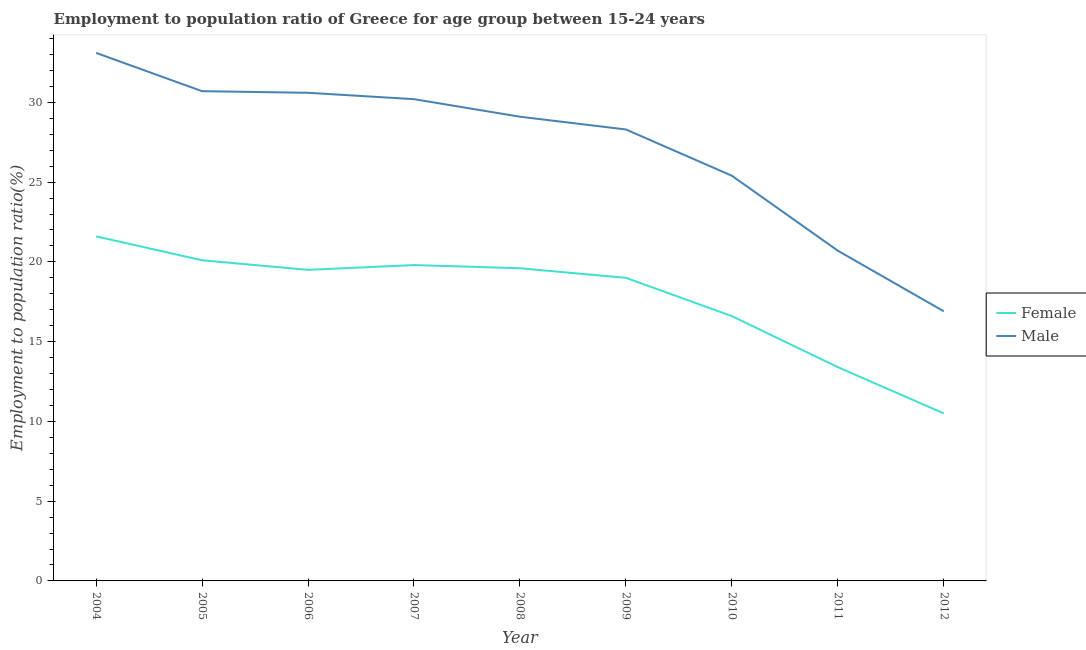How many different coloured lines are there?
Provide a short and direct response. 2. What is the employment to population ratio(male) in 2009?
Give a very brief answer. 28.3. Across all years, what is the maximum employment to population ratio(female)?
Keep it short and to the point. 21.6. What is the total employment to population ratio(male) in the graph?
Ensure brevity in your answer.  245. What is the difference between the employment to population ratio(female) in 2005 and that in 2006?
Offer a terse response. 0.6. What is the difference between the employment to population ratio(female) in 2007 and the employment to population ratio(male) in 2010?
Offer a very short reply. -5.6. What is the average employment to population ratio(male) per year?
Offer a very short reply. 27.22. In the year 2005, what is the difference between the employment to population ratio(male) and employment to population ratio(female)?
Make the answer very short. 10.6. What is the ratio of the employment to population ratio(male) in 2005 to that in 2009?
Keep it short and to the point. 1.08. Is the employment to population ratio(male) in 2004 less than that in 2006?
Your answer should be very brief. No. What is the difference between the highest and the second highest employment to population ratio(male)?
Your answer should be very brief. 2.4. What is the difference between the highest and the lowest employment to population ratio(male)?
Make the answer very short. 16.2. In how many years, is the employment to population ratio(female) greater than the average employment to population ratio(female) taken over all years?
Provide a short and direct response. 6. Is the sum of the employment to population ratio(female) in 2005 and 2012 greater than the maximum employment to population ratio(male) across all years?
Your answer should be compact. No. Is the employment to population ratio(female) strictly greater than the employment to population ratio(male) over the years?
Offer a terse response. No. Is the employment to population ratio(male) strictly less than the employment to population ratio(female) over the years?
Keep it short and to the point. No. How many lines are there?
Offer a terse response. 2. What is the difference between two consecutive major ticks on the Y-axis?
Give a very brief answer. 5. Are the values on the major ticks of Y-axis written in scientific E-notation?
Offer a terse response. No. Does the graph contain any zero values?
Make the answer very short. No. How are the legend labels stacked?
Provide a succinct answer. Vertical. What is the title of the graph?
Provide a succinct answer. Employment to population ratio of Greece for age group between 15-24 years. Does "International Tourists" appear as one of the legend labels in the graph?
Provide a short and direct response. No. What is the label or title of the Y-axis?
Offer a very short reply. Employment to population ratio(%). What is the Employment to population ratio(%) of Female in 2004?
Provide a succinct answer. 21.6. What is the Employment to population ratio(%) in Male in 2004?
Give a very brief answer. 33.1. What is the Employment to population ratio(%) in Female in 2005?
Offer a very short reply. 20.1. What is the Employment to population ratio(%) of Male in 2005?
Your answer should be very brief. 30.7. What is the Employment to population ratio(%) of Female in 2006?
Give a very brief answer. 19.5. What is the Employment to population ratio(%) of Male in 2006?
Offer a terse response. 30.6. What is the Employment to population ratio(%) in Female in 2007?
Provide a short and direct response. 19.8. What is the Employment to population ratio(%) in Male in 2007?
Your response must be concise. 30.2. What is the Employment to population ratio(%) in Female in 2008?
Provide a short and direct response. 19.6. What is the Employment to population ratio(%) in Male in 2008?
Offer a terse response. 29.1. What is the Employment to population ratio(%) in Male in 2009?
Provide a succinct answer. 28.3. What is the Employment to population ratio(%) of Female in 2010?
Keep it short and to the point. 16.6. What is the Employment to population ratio(%) of Male in 2010?
Your answer should be very brief. 25.4. What is the Employment to population ratio(%) in Female in 2011?
Offer a very short reply. 13.4. What is the Employment to population ratio(%) of Male in 2011?
Offer a terse response. 20.7. What is the Employment to population ratio(%) of Male in 2012?
Your response must be concise. 16.9. Across all years, what is the maximum Employment to population ratio(%) of Female?
Offer a terse response. 21.6. Across all years, what is the maximum Employment to population ratio(%) in Male?
Ensure brevity in your answer.  33.1. Across all years, what is the minimum Employment to population ratio(%) in Male?
Offer a very short reply. 16.9. What is the total Employment to population ratio(%) of Female in the graph?
Offer a terse response. 160.1. What is the total Employment to population ratio(%) in Male in the graph?
Your answer should be very brief. 245. What is the difference between the Employment to population ratio(%) of Male in 2004 and that in 2005?
Give a very brief answer. 2.4. What is the difference between the Employment to population ratio(%) in Female in 2004 and that in 2006?
Provide a succinct answer. 2.1. What is the difference between the Employment to population ratio(%) in Female in 2004 and that in 2007?
Provide a short and direct response. 1.8. What is the difference between the Employment to population ratio(%) of Male in 2004 and that in 2007?
Offer a terse response. 2.9. What is the difference between the Employment to population ratio(%) in Female in 2004 and that in 2009?
Offer a terse response. 2.6. What is the difference between the Employment to population ratio(%) in Female in 2004 and that in 2011?
Offer a very short reply. 8.2. What is the difference between the Employment to population ratio(%) in Male in 2004 and that in 2011?
Your response must be concise. 12.4. What is the difference between the Employment to population ratio(%) of Female in 2004 and that in 2012?
Provide a succinct answer. 11.1. What is the difference between the Employment to population ratio(%) of Male in 2004 and that in 2012?
Keep it short and to the point. 16.2. What is the difference between the Employment to population ratio(%) of Female in 2005 and that in 2006?
Provide a succinct answer. 0.6. What is the difference between the Employment to population ratio(%) of Male in 2005 and that in 2006?
Your answer should be compact. 0.1. What is the difference between the Employment to population ratio(%) of Male in 2005 and that in 2007?
Keep it short and to the point. 0.5. What is the difference between the Employment to population ratio(%) in Female in 2005 and that in 2009?
Your answer should be compact. 1.1. What is the difference between the Employment to population ratio(%) in Male in 2005 and that in 2010?
Keep it short and to the point. 5.3. What is the difference between the Employment to population ratio(%) of Female in 2005 and that in 2011?
Your answer should be compact. 6.7. What is the difference between the Employment to population ratio(%) of Male in 2006 and that in 2007?
Your answer should be compact. 0.4. What is the difference between the Employment to population ratio(%) of Female in 2006 and that in 2009?
Provide a short and direct response. 0.5. What is the difference between the Employment to population ratio(%) in Male in 2006 and that in 2009?
Ensure brevity in your answer.  2.3. What is the difference between the Employment to population ratio(%) of Female in 2006 and that in 2010?
Your answer should be very brief. 2.9. What is the difference between the Employment to population ratio(%) of Male in 2006 and that in 2010?
Keep it short and to the point. 5.2. What is the difference between the Employment to population ratio(%) in Male in 2006 and that in 2012?
Offer a terse response. 13.7. What is the difference between the Employment to population ratio(%) of Female in 2007 and that in 2009?
Your response must be concise. 0.8. What is the difference between the Employment to population ratio(%) in Male in 2007 and that in 2009?
Ensure brevity in your answer.  1.9. What is the difference between the Employment to population ratio(%) of Female in 2007 and that in 2010?
Your response must be concise. 3.2. What is the difference between the Employment to population ratio(%) in Male in 2007 and that in 2010?
Keep it short and to the point. 4.8. What is the difference between the Employment to population ratio(%) in Male in 2007 and that in 2011?
Make the answer very short. 9.5. What is the difference between the Employment to population ratio(%) in Male in 2008 and that in 2009?
Offer a very short reply. 0.8. What is the difference between the Employment to population ratio(%) of Female in 2008 and that in 2010?
Make the answer very short. 3. What is the difference between the Employment to population ratio(%) of Female in 2009 and that in 2010?
Keep it short and to the point. 2.4. What is the difference between the Employment to population ratio(%) in Female in 2009 and that in 2011?
Provide a succinct answer. 5.6. What is the difference between the Employment to population ratio(%) in Male in 2009 and that in 2011?
Keep it short and to the point. 7.6. What is the difference between the Employment to population ratio(%) in Female in 2009 and that in 2012?
Give a very brief answer. 8.5. What is the difference between the Employment to population ratio(%) of Male in 2010 and that in 2011?
Offer a very short reply. 4.7. What is the difference between the Employment to population ratio(%) of Male in 2010 and that in 2012?
Your answer should be compact. 8.5. What is the difference between the Employment to population ratio(%) in Female in 2011 and that in 2012?
Your response must be concise. 2.9. What is the difference between the Employment to population ratio(%) in Female in 2004 and the Employment to population ratio(%) in Male in 2005?
Keep it short and to the point. -9.1. What is the difference between the Employment to population ratio(%) of Female in 2004 and the Employment to population ratio(%) of Male in 2008?
Ensure brevity in your answer.  -7.5. What is the difference between the Employment to population ratio(%) of Female in 2004 and the Employment to population ratio(%) of Male in 2009?
Your answer should be very brief. -6.7. What is the difference between the Employment to population ratio(%) of Female in 2004 and the Employment to population ratio(%) of Male in 2010?
Ensure brevity in your answer.  -3.8. What is the difference between the Employment to population ratio(%) of Female in 2004 and the Employment to population ratio(%) of Male in 2011?
Your response must be concise. 0.9. What is the difference between the Employment to population ratio(%) of Female in 2005 and the Employment to population ratio(%) of Male in 2006?
Your answer should be very brief. -10.5. What is the difference between the Employment to population ratio(%) in Female in 2005 and the Employment to population ratio(%) in Male in 2007?
Provide a succinct answer. -10.1. What is the difference between the Employment to population ratio(%) in Female in 2005 and the Employment to population ratio(%) in Male in 2008?
Provide a succinct answer. -9. What is the difference between the Employment to population ratio(%) in Female in 2005 and the Employment to population ratio(%) in Male in 2011?
Your response must be concise. -0.6. What is the difference between the Employment to population ratio(%) in Female in 2006 and the Employment to population ratio(%) in Male in 2012?
Your answer should be very brief. 2.6. What is the difference between the Employment to population ratio(%) of Female in 2007 and the Employment to population ratio(%) of Male in 2008?
Keep it short and to the point. -9.3. What is the difference between the Employment to population ratio(%) in Female in 2007 and the Employment to population ratio(%) in Male in 2010?
Provide a succinct answer. -5.6. What is the difference between the Employment to population ratio(%) in Female in 2007 and the Employment to population ratio(%) in Male in 2011?
Provide a succinct answer. -0.9. What is the difference between the Employment to population ratio(%) of Female in 2009 and the Employment to population ratio(%) of Male in 2010?
Offer a very short reply. -6.4. What is the difference between the Employment to population ratio(%) in Female in 2009 and the Employment to population ratio(%) in Male in 2012?
Offer a very short reply. 2.1. What is the difference between the Employment to population ratio(%) in Female in 2010 and the Employment to population ratio(%) in Male in 2011?
Your answer should be very brief. -4.1. What is the difference between the Employment to population ratio(%) of Female in 2010 and the Employment to population ratio(%) of Male in 2012?
Provide a succinct answer. -0.3. What is the average Employment to population ratio(%) of Female per year?
Make the answer very short. 17.79. What is the average Employment to population ratio(%) in Male per year?
Your answer should be very brief. 27.22. In the year 2004, what is the difference between the Employment to population ratio(%) in Female and Employment to population ratio(%) in Male?
Provide a succinct answer. -11.5. In the year 2005, what is the difference between the Employment to population ratio(%) in Female and Employment to population ratio(%) in Male?
Offer a very short reply. -10.6. What is the ratio of the Employment to population ratio(%) of Female in 2004 to that in 2005?
Provide a succinct answer. 1.07. What is the ratio of the Employment to population ratio(%) of Male in 2004 to that in 2005?
Offer a very short reply. 1.08. What is the ratio of the Employment to population ratio(%) of Female in 2004 to that in 2006?
Ensure brevity in your answer.  1.11. What is the ratio of the Employment to population ratio(%) of Male in 2004 to that in 2006?
Offer a very short reply. 1.08. What is the ratio of the Employment to population ratio(%) of Female in 2004 to that in 2007?
Make the answer very short. 1.09. What is the ratio of the Employment to population ratio(%) in Male in 2004 to that in 2007?
Give a very brief answer. 1.1. What is the ratio of the Employment to population ratio(%) of Female in 2004 to that in 2008?
Provide a succinct answer. 1.1. What is the ratio of the Employment to population ratio(%) in Male in 2004 to that in 2008?
Your response must be concise. 1.14. What is the ratio of the Employment to population ratio(%) of Female in 2004 to that in 2009?
Your answer should be very brief. 1.14. What is the ratio of the Employment to population ratio(%) of Male in 2004 to that in 2009?
Give a very brief answer. 1.17. What is the ratio of the Employment to population ratio(%) of Female in 2004 to that in 2010?
Give a very brief answer. 1.3. What is the ratio of the Employment to population ratio(%) of Male in 2004 to that in 2010?
Your response must be concise. 1.3. What is the ratio of the Employment to population ratio(%) of Female in 2004 to that in 2011?
Your answer should be very brief. 1.61. What is the ratio of the Employment to population ratio(%) in Male in 2004 to that in 2011?
Ensure brevity in your answer.  1.6. What is the ratio of the Employment to population ratio(%) of Female in 2004 to that in 2012?
Ensure brevity in your answer.  2.06. What is the ratio of the Employment to population ratio(%) in Male in 2004 to that in 2012?
Your answer should be compact. 1.96. What is the ratio of the Employment to population ratio(%) in Female in 2005 to that in 2006?
Your answer should be compact. 1.03. What is the ratio of the Employment to population ratio(%) in Male in 2005 to that in 2006?
Your response must be concise. 1. What is the ratio of the Employment to population ratio(%) of Female in 2005 to that in 2007?
Offer a terse response. 1.02. What is the ratio of the Employment to population ratio(%) of Male in 2005 to that in 2007?
Your answer should be compact. 1.02. What is the ratio of the Employment to population ratio(%) of Female in 2005 to that in 2008?
Offer a very short reply. 1.03. What is the ratio of the Employment to population ratio(%) of Male in 2005 to that in 2008?
Your response must be concise. 1.05. What is the ratio of the Employment to population ratio(%) of Female in 2005 to that in 2009?
Your answer should be very brief. 1.06. What is the ratio of the Employment to population ratio(%) in Male in 2005 to that in 2009?
Your answer should be compact. 1.08. What is the ratio of the Employment to population ratio(%) in Female in 2005 to that in 2010?
Make the answer very short. 1.21. What is the ratio of the Employment to population ratio(%) in Male in 2005 to that in 2010?
Offer a terse response. 1.21. What is the ratio of the Employment to population ratio(%) in Male in 2005 to that in 2011?
Offer a very short reply. 1.48. What is the ratio of the Employment to population ratio(%) of Female in 2005 to that in 2012?
Provide a short and direct response. 1.91. What is the ratio of the Employment to population ratio(%) of Male in 2005 to that in 2012?
Your answer should be very brief. 1.82. What is the ratio of the Employment to population ratio(%) in Female in 2006 to that in 2007?
Your response must be concise. 0.98. What is the ratio of the Employment to population ratio(%) of Male in 2006 to that in 2007?
Keep it short and to the point. 1.01. What is the ratio of the Employment to population ratio(%) in Female in 2006 to that in 2008?
Provide a short and direct response. 0.99. What is the ratio of the Employment to population ratio(%) in Male in 2006 to that in 2008?
Keep it short and to the point. 1.05. What is the ratio of the Employment to population ratio(%) in Female in 2006 to that in 2009?
Offer a terse response. 1.03. What is the ratio of the Employment to population ratio(%) in Male in 2006 to that in 2009?
Provide a succinct answer. 1.08. What is the ratio of the Employment to population ratio(%) in Female in 2006 to that in 2010?
Provide a short and direct response. 1.17. What is the ratio of the Employment to population ratio(%) of Male in 2006 to that in 2010?
Keep it short and to the point. 1.2. What is the ratio of the Employment to population ratio(%) of Female in 2006 to that in 2011?
Your answer should be very brief. 1.46. What is the ratio of the Employment to population ratio(%) of Male in 2006 to that in 2011?
Give a very brief answer. 1.48. What is the ratio of the Employment to population ratio(%) of Female in 2006 to that in 2012?
Offer a terse response. 1.86. What is the ratio of the Employment to population ratio(%) in Male in 2006 to that in 2012?
Offer a very short reply. 1.81. What is the ratio of the Employment to population ratio(%) in Female in 2007 to that in 2008?
Give a very brief answer. 1.01. What is the ratio of the Employment to population ratio(%) in Male in 2007 to that in 2008?
Offer a very short reply. 1.04. What is the ratio of the Employment to population ratio(%) in Female in 2007 to that in 2009?
Offer a terse response. 1.04. What is the ratio of the Employment to population ratio(%) of Male in 2007 to that in 2009?
Ensure brevity in your answer.  1.07. What is the ratio of the Employment to population ratio(%) of Female in 2007 to that in 2010?
Your answer should be compact. 1.19. What is the ratio of the Employment to population ratio(%) in Male in 2007 to that in 2010?
Ensure brevity in your answer.  1.19. What is the ratio of the Employment to population ratio(%) in Female in 2007 to that in 2011?
Make the answer very short. 1.48. What is the ratio of the Employment to population ratio(%) of Male in 2007 to that in 2011?
Your answer should be very brief. 1.46. What is the ratio of the Employment to population ratio(%) in Female in 2007 to that in 2012?
Your answer should be compact. 1.89. What is the ratio of the Employment to population ratio(%) of Male in 2007 to that in 2012?
Provide a short and direct response. 1.79. What is the ratio of the Employment to population ratio(%) of Female in 2008 to that in 2009?
Keep it short and to the point. 1.03. What is the ratio of the Employment to population ratio(%) in Male in 2008 to that in 2009?
Give a very brief answer. 1.03. What is the ratio of the Employment to population ratio(%) in Female in 2008 to that in 2010?
Keep it short and to the point. 1.18. What is the ratio of the Employment to population ratio(%) in Male in 2008 to that in 2010?
Ensure brevity in your answer.  1.15. What is the ratio of the Employment to population ratio(%) of Female in 2008 to that in 2011?
Your answer should be very brief. 1.46. What is the ratio of the Employment to population ratio(%) in Male in 2008 to that in 2011?
Offer a very short reply. 1.41. What is the ratio of the Employment to population ratio(%) in Female in 2008 to that in 2012?
Your answer should be very brief. 1.87. What is the ratio of the Employment to population ratio(%) of Male in 2008 to that in 2012?
Offer a terse response. 1.72. What is the ratio of the Employment to population ratio(%) of Female in 2009 to that in 2010?
Offer a very short reply. 1.14. What is the ratio of the Employment to population ratio(%) in Male in 2009 to that in 2010?
Your answer should be compact. 1.11. What is the ratio of the Employment to population ratio(%) of Female in 2009 to that in 2011?
Your response must be concise. 1.42. What is the ratio of the Employment to population ratio(%) in Male in 2009 to that in 2011?
Your answer should be very brief. 1.37. What is the ratio of the Employment to population ratio(%) in Female in 2009 to that in 2012?
Offer a very short reply. 1.81. What is the ratio of the Employment to population ratio(%) in Male in 2009 to that in 2012?
Make the answer very short. 1.67. What is the ratio of the Employment to population ratio(%) in Female in 2010 to that in 2011?
Offer a terse response. 1.24. What is the ratio of the Employment to population ratio(%) of Male in 2010 to that in 2011?
Offer a very short reply. 1.23. What is the ratio of the Employment to population ratio(%) in Female in 2010 to that in 2012?
Your answer should be very brief. 1.58. What is the ratio of the Employment to population ratio(%) of Male in 2010 to that in 2012?
Make the answer very short. 1.5. What is the ratio of the Employment to population ratio(%) of Female in 2011 to that in 2012?
Give a very brief answer. 1.28. What is the ratio of the Employment to population ratio(%) in Male in 2011 to that in 2012?
Make the answer very short. 1.22. What is the difference between the highest and the second highest Employment to population ratio(%) of Male?
Make the answer very short. 2.4. What is the difference between the highest and the lowest Employment to population ratio(%) in Male?
Your response must be concise. 16.2. 